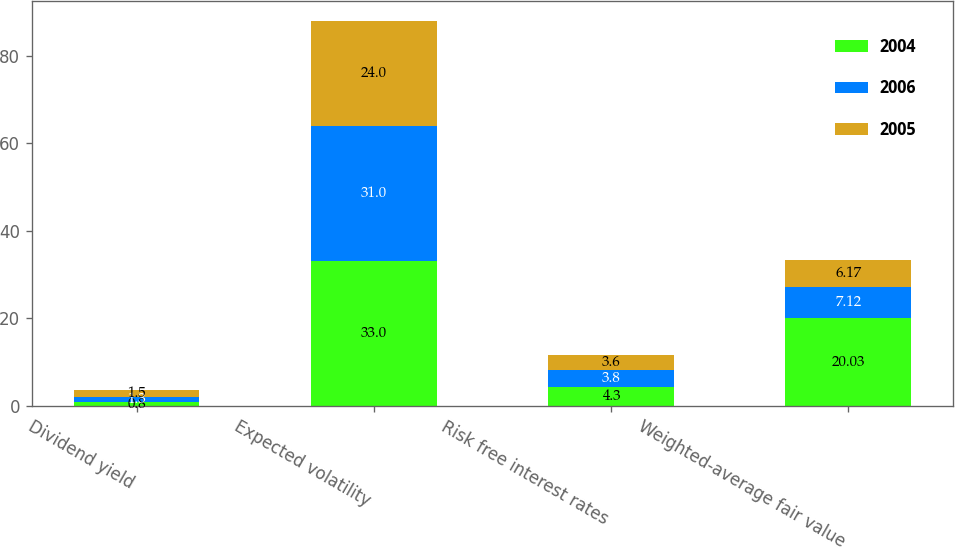Convert chart to OTSL. <chart><loc_0><loc_0><loc_500><loc_500><stacked_bar_chart><ecel><fcel>Dividend yield<fcel>Expected volatility<fcel>Risk free interest rates<fcel>Weighted-average fair value<nl><fcel>2004<fcel>0.8<fcel>33<fcel>4.3<fcel>20.03<nl><fcel>2006<fcel>1.3<fcel>31<fcel>3.8<fcel>7.12<nl><fcel>2005<fcel>1.5<fcel>24<fcel>3.6<fcel>6.17<nl></chart> 